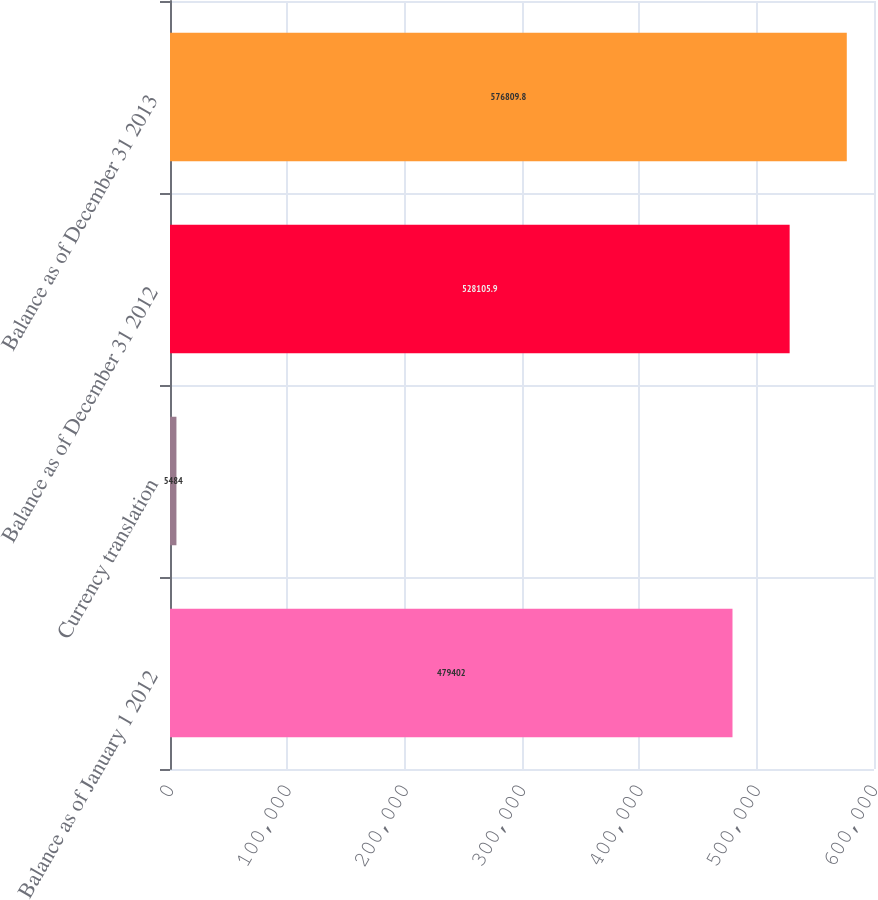Convert chart. <chart><loc_0><loc_0><loc_500><loc_500><bar_chart><fcel>Balance as of January 1 2012<fcel>Currency translation<fcel>Balance as of December 31 2012<fcel>Balance as of December 31 2013<nl><fcel>479402<fcel>5484<fcel>528106<fcel>576810<nl></chart> 